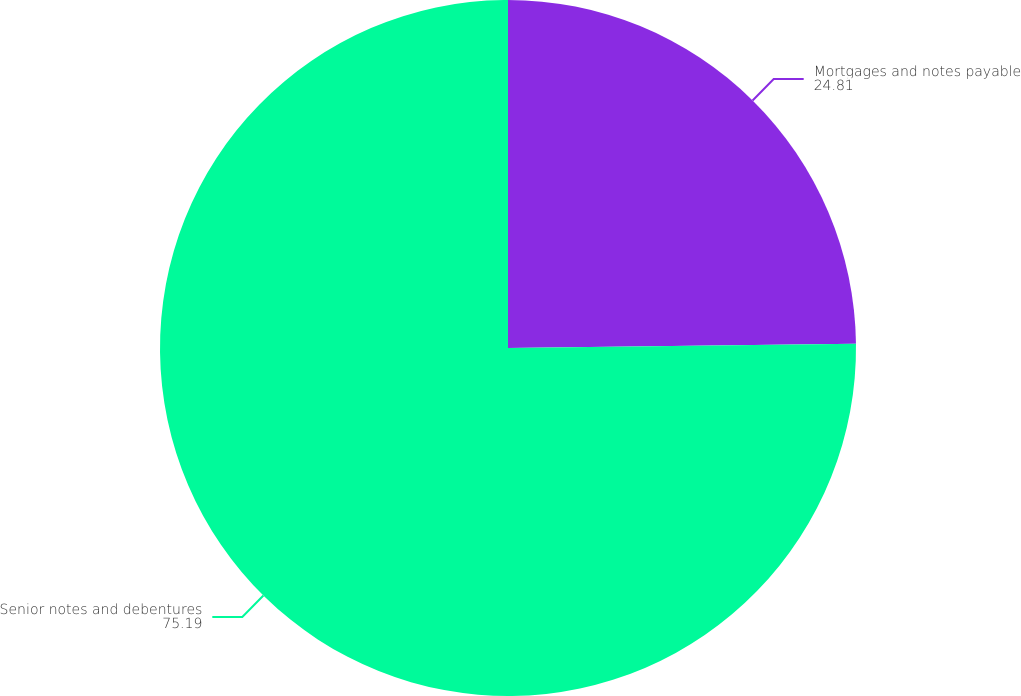Convert chart. <chart><loc_0><loc_0><loc_500><loc_500><pie_chart><fcel>Mortgages and notes payable<fcel>Senior notes and debentures<nl><fcel>24.81%<fcel>75.19%<nl></chart> 